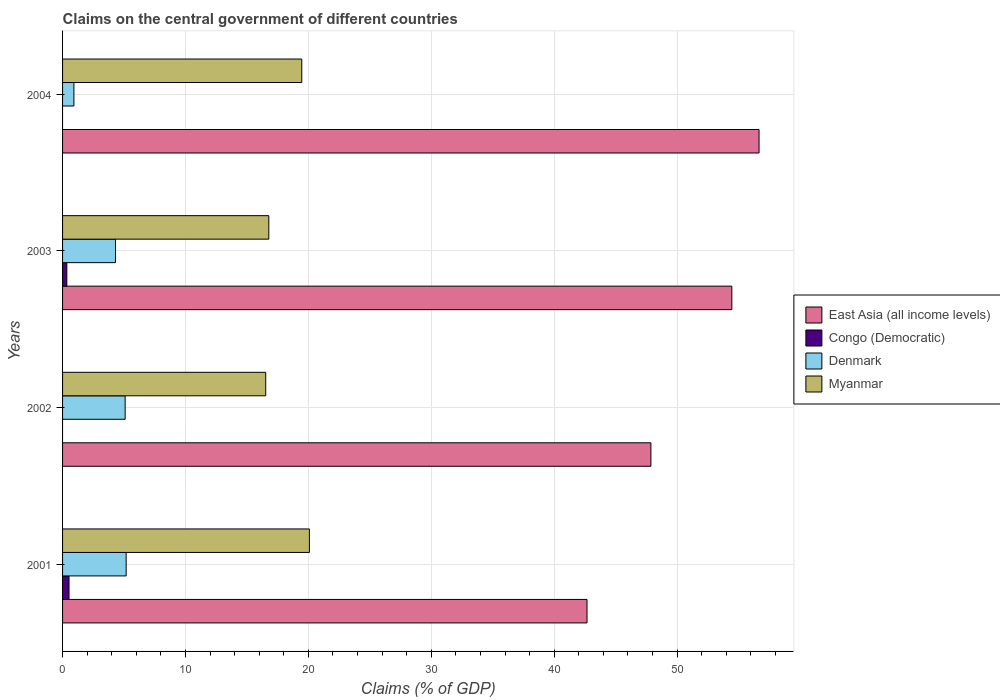How many groups of bars are there?
Offer a very short reply. 4. Are the number of bars on each tick of the Y-axis equal?
Your answer should be very brief. No. How many bars are there on the 3rd tick from the top?
Offer a terse response. 3. What is the label of the 4th group of bars from the top?
Provide a succinct answer. 2001. What is the percentage of GDP claimed on the central government in Myanmar in 2001?
Your answer should be compact. 20.08. Across all years, what is the maximum percentage of GDP claimed on the central government in Denmark?
Offer a very short reply. 5.17. Across all years, what is the minimum percentage of GDP claimed on the central government in East Asia (all income levels)?
Provide a short and direct response. 42.67. What is the total percentage of GDP claimed on the central government in Congo (Democratic) in the graph?
Provide a succinct answer. 0.87. What is the difference between the percentage of GDP claimed on the central government in Myanmar in 2003 and that in 2004?
Ensure brevity in your answer.  -2.68. What is the difference between the percentage of GDP claimed on the central government in East Asia (all income levels) in 2004 and the percentage of GDP claimed on the central government in Myanmar in 2003?
Your answer should be very brief. 39.89. What is the average percentage of GDP claimed on the central government in Congo (Democratic) per year?
Your answer should be compact. 0.22. In the year 2001, what is the difference between the percentage of GDP claimed on the central government in East Asia (all income levels) and percentage of GDP claimed on the central government in Myanmar?
Keep it short and to the point. 22.59. In how many years, is the percentage of GDP claimed on the central government in Congo (Democratic) greater than 12 %?
Provide a succinct answer. 0. What is the ratio of the percentage of GDP claimed on the central government in Myanmar in 2002 to that in 2003?
Provide a short and direct response. 0.98. Is the percentage of GDP claimed on the central government in Denmark in 2001 less than that in 2004?
Make the answer very short. No. Is the difference between the percentage of GDP claimed on the central government in East Asia (all income levels) in 2002 and 2003 greater than the difference between the percentage of GDP claimed on the central government in Myanmar in 2002 and 2003?
Your response must be concise. No. What is the difference between the highest and the second highest percentage of GDP claimed on the central government in Myanmar?
Keep it short and to the point. 0.62. What is the difference between the highest and the lowest percentage of GDP claimed on the central government in Denmark?
Offer a very short reply. 4.25. In how many years, is the percentage of GDP claimed on the central government in Congo (Democratic) greater than the average percentage of GDP claimed on the central government in Congo (Democratic) taken over all years?
Ensure brevity in your answer.  2. Is the sum of the percentage of GDP claimed on the central government in East Asia (all income levels) in 2001 and 2002 greater than the maximum percentage of GDP claimed on the central government in Denmark across all years?
Your response must be concise. Yes. How many bars are there?
Provide a short and direct response. 14. Are all the bars in the graph horizontal?
Ensure brevity in your answer.  Yes. How many years are there in the graph?
Offer a very short reply. 4. Are the values on the major ticks of X-axis written in scientific E-notation?
Provide a short and direct response. No. Does the graph contain any zero values?
Provide a short and direct response. Yes. Does the graph contain grids?
Ensure brevity in your answer.  Yes. Where does the legend appear in the graph?
Offer a very short reply. Center right. How many legend labels are there?
Provide a succinct answer. 4. What is the title of the graph?
Your response must be concise. Claims on the central government of different countries. Does "Latvia" appear as one of the legend labels in the graph?
Your answer should be very brief. No. What is the label or title of the X-axis?
Provide a succinct answer. Claims (% of GDP). What is the label or title of the Y-axis?
Keep it short and to the point. Years. What is the Claims (% of GDP) of East Asia (all income levels) in 2001?
Your answer should be compact. 42.67. What is the Claims (% of GDP) in Congo (Democratic) in 2001?
Offer a terse response. 0.53. What is the Claims (% of GDP) in Denmark in 2001?
Offer a very short reply. 5.17. What is the Claims (% of GDP) of Myanmar in 2001?
Your response must be concise. 20.08. What is the Claims (% of GDP) of East Asia (all income levels) in 2002?
Offer a terse response. 47.87. What is the Claims (% of GDP) in Congo (Democratic) in 2002?
Provide a short and direct response. 0. What is the Claims (% of GDP) of Denmark in 2002?
Offer a very short reply. 5.09. What is the Claims (% of GDP) in Myanmar in 2002?
Your answer should be compact. 16.53. What is the Claims (% of GDP) of East Asia (all income levels) in 2003?
Offer a terse response. 54.45. What is the Claims (% of GDP) of Congo (Democratic) in 2003?
Provide a succinct answer. 0.35. What is the Claims (% of GDP) in Denmark in 2003?
Make the answer very short. 4.31. What is the Claims (% of GDP) of Myanmar in 2003?
Ensure brevity in your answer.  16.78. What is the Claims (% of GDP) of East Asia (all income levels) in 2004?
Offer a terse response. 56.67. What is the Claims (% of GDP) in Denmark in 2004?
Provide a short and direct response. 0.92. What is the Claims (% of GDP) of Myanmar in 2004?
Make the answer very short. 19.46. Across all years, what is the maximum Claims (% of GDP) in East Asia (all income levels)?
Ensure brevity in your answer.  56.67. Across all years, what is the maximum Claims (% of GDP) in Congo (Democratic)?
Provide a succinct answer. 0.53. Across all years, what is the maximum Claims (% of GDP) in Denmark?
Make the answer very short. 5.17. Across all years, what is the maximum Claims (% of GDP) in Myanmar?
Provide a succinct answer. 20.08. Across all years, what is the minimum Claims (% of GDP) of East Asia (all income levels)?
Offer a terse response. 42.67. Across all years, what is the minimum Claims (% of GDP) in Denmark?
Offer a very short reply. 0.92. Across all years, what is the minimum Claims (% of GDP) of Myanmar?
Your answer should be compact. 16.53. What is the total Claims (% of GDP) of East Asia (all income levels) in the graph?
Ensure brevity in your answer.  201.65. What is the total Claims (% of GDP) of Congo (Democratic) in the graph?
Your response must be concise. 0.87. What is the total Claims (% of GDP) of Denmark in the graph?
Give a very brief answer. 15.5. What is the total Claims (% of GDP) in Myanmar in the graph?
Your response must be concise. 72.85. What is the difference between the Claims (% of GDP) in East Asia (all income levels) in 2001 and that in 2002?
Provide a short and direct response. -5.2. What is the difference between the Claims (% of GDP) of Denmark in 2001 and that in 2002?
Provide a succinct answer. 0.08. What is the difference between the Claims (% of GDP) in Myanmar in 2001 and that in 2002?
Give a very brief answer. 3.55. What is the difference between the Claims (% of GDP) in East Asia (all income levels) in 2001 and that in 2003?
Make the answer very short. -11.78. What is the difference between the Claims (% of GDP) in Congo (Democratic) in 2001 and that in 2003?
Your answer should be very brief. 0.18. What is the difference between the Claims (% of GDP) of Denmark in 2001 and that in 2003?
Provide a short and direct response. 0.87. What is the difference between the Claims (% of GDP) in Myanmar in 2001 and that in 2003?
Provide a short and direct response. 3.3. What is the difference between the Claims (% of GDP) in East Asia (all income levels) in 2001 and that in 2004?
Provide a short and direct response. -14. What is the difference between the Claims (% of GDP) in Denmark in 2001 and that in 2004?
Keep it short and to the point. 4.25. What is the difference between the Claims (% of GDP) of Myanmar in 2001 and that in 2004?
Provide a succinct answer. 0.62. What is the difference between the Claims (% of GDP) of East Asia (all income levels) in 2002 and that in 2003?
Offer a very short reply. -6.58. What is the difference between the Claims (% of GDP) of Denmark in 2002 and that in 2003?
Give a very brief answer. 0.78. What is the difference between the Claims (% of GDP) in Myanmar in 2002 and that in 2003?
Give a very brief answer. -0.25. What is the difference between the Claims (% of GDP) in East Asia (all income levels) in 2002 and that in 2004?
Make the answer very short. -8.8. What is the difference between the Claims (% of GDP) in Denmark in 2002 and that in 2004?
Make the answer very short. 4.17. What is the difference between the Claims (% of GDP) of Myanmar in 2002 and that in 2004?
Give a very brief answer. -2.93. What is the difference between the Claims (% of GDP) of East Asia (all income levels) in 2003 and that in 2004?
Make the answer very short. -2.21. What is the difference between the Claims (% of GDP) in Denmark in 2003 and that in 2004?
Give a very brief answer. 3.39. What is the difference between the Claims (% of GDP) in Myanmar in 2003 and that in 2004?
Provide a succinct answer. -2.68. What is the difference between the Claims (% of GDP) in East Asia (all income levels) in 2001 and the Claims (% of GDP) in Denmark in 2002?
Your answer should be compact. 37.58. What is the difference between the Claims (% of GDP) in East Asia (all income levels) in 2001 and the Claims (% of GDP) in Myanmar in 2002?
Offer a terse response. 26.14. What is the difference between the Claims (% of GDP) of Congo (Democratic) in 2001 and the Claims (% of GDP) of Denmark in 2002?
Provide a succinct answer. -4.57. What is the difference between the Claims (% of GDP) in Congo (Democratic) in 2001 and the Claims (% of GDP) in Myanmar in 2002?
Offer a terse response. -16. What is the difference between the Claims (% of GDP) in Denmark in 2001 and the Claims (% of GDP) in Myanmar in 2002?
Offer a terse response. -11.35. What is the difference between the Claims (% of GDP) of East Asia (all income levels) in 2001 and the Claims (% of GDP) of Congo (Democratic) in 2003?
Ensure brevity in your answer.  42.32. What is the difference between the Claims (% of GDP) in East Asia (all income levels) in 2001 and the Claims (% of GDP) in Denmark in 2003?
Your answer should be compact. 38.36. What is the difference between the Claims (% of GDP) of East Asia (all income levels) in 2001 and the Claims (% of GDP) of Myanmar in 2003?
Offer a very short reply. 25.89. What is the difference between the Claims (% of GDP) of Congo (Democratic) in 2001 and the Claims (% of GDP) of Denmark in 2003?
Keep it short and to the point. -3.78. What is the difference between the Claims (% of GDP) in Congo (Democratic) in 2001 and the Claims (% of GDP) in Myanmar in 2003?
Make the answer very short. -16.25. What is the difference between the Claims (% of GDP) of Denmark in 2001 and the Claims (% of GDP) of Myanmar in 2003?
Keep it short and to the point. -11.61. What is the difference between the Claims (% of GDP) of East Asia (all income levels) in 2001 and the Claims (% of GDP) of Denmark in 2004?
Your response must be concise. 41.75. What is the difference between the Claims (% of GDP) in East Asia (all income levels) in 2001 and the Claims (% of GDP) in Myanmar in 2004?
Ensure brevity in your answer.  23.21. What is the difference between the Claims (% of GDP) in Congo (Democratic) in 2001 and the Claims (% of GDP) in Denmark in 2004?
Provide a succinct answer. -0.4. What is the difference between the Claims (% of GDP) of Congo (Democratic) in 2001 and the Claims (% of GDP) of Myanmar in 2004?
Make the answer very short. -18.94. What is the difference between the Claims (% of GDP) of Denmark in 2001 and the Claims (% of GDP) of Myanmar in 2004?
Give a very brief answer. -14.29. What is the difference between the Claims (% of GDP) of East Asia (all income levels) in 2002 and the Claims (% of GDP) of Congo (Democratic) in 2003?
Give a very brief answer. 47.52. What is the difference between the Claims (% of GDP) of East Asia (all income levels) in 2002 and the Claims (% of GDP) of Denmark in 2003?
Provide a short and direct response. 43.56. What is the difference between the Claims (% of GDP) in East Asia (all income levels) in 2002 and the Claims (% of GDP) in Myanmar in 2003?
Keep it short and to the point. 31.09. What is the difference between the Claims (% of GDP) in Denmark in 2002 and the Claims (% of GDP) in Myanmar in 2003?
Your answer should be compact. -11.69. What is the difference between the Claims (% of GDP) of East Asia (all income levels) in 2002 and the Claims (% of GDP) of Denmark in 2004?
Give a very brief answer. 46.94. What is the difference between the Claims (% of GDP) of East Asia (all income levels) in 2002 and the Claims (% of GDP) of Myanmar in 2004?
Give a very brief answer. 28.41. What is the difference between the Claims (% of GDP) of Denmark in 2002 and the Claims (% of GDP) of Myanmar in 2004?
Give a very brief answer. -14.37. What is the difference between the Claims (% of GDP) of East Asia (all income levels) in 2003 and the Claims (% of GDP) of Denmark in 2004?
Offer a terse response. 53.53. What is the difference between the Claims (% of GDP) of East Asia (all income levels) in 2003 and the Claims (% of GDP) of Myanmar in 2004?
Make the answer very short. 34.99. What is the difference between the Claims (% of GDP) in Congo (Democratic) in 2003 and the Claims (% of GDP) in Denmark in 2004?
Your answer should be very brief. -0.58. What is the difference between the Claims (% of GDP) in Congo (Democratic) in 2003 and the Claims (% of GDP) in Myanmar in 2004?
Offer a very short reply. -19.11. What is the difference between the Claims (% of GDP) in Denmark in 2003 and the Claims (% of GDP) in Myanmar in 2004?
Make the answer very short. -15.15. What is the average Claims (% of GDP) in East Asia (all income levels) per year?
Your answer should be compact. 50.41. What is the average Claims (% of GDP) of Congo (Democratic) per year?
Your response must be concise. 0.22. What is the average Claims (% of GDP) in Denmark per year?
Your answer should be very brief. 3.87. What is the average Claims (% of GDP) of Myanmar per year?
Ensure brevity in your answer.  18.21. In the year 2001, what is the difference between the Claims (% of GDP) in East Asia (all income levels) and Claims (% of GDP) in Congo (Democratic)?
Your answer should be compact. 42.14. In the year 2001, what is the difference between the Claims (% of GDP) in East Asia (all income levels) and Claims (% of GDP) in Denmark?
Provide a short and direct response. 37.5. In the year 2001, what is the difference between the Claims (% of GDP) of East Asia (all income levels) and Claims (% of GDP) of Myanmar?
Provide a succinct answer. 22.59. In the year 2001, what is the difference between the Claims (% of GDP) in Congo (Democratic) and Claims (% of GDP) in Denmark?
Offer a very short reply. -4.65. In the year 2001, what is the difference between the Claims (% of GDP) of Congo (Democratic) and Claims (% of GDP) of Myanmar?
Your answer should be compact. -19.56. In the year 2001, what is the difference between the Claims (% of GDP) of Denmark and Claims (% of GDP) of Myanmar?
Keep it short and to the point. -14.91. In the year 2002, what is the difference between the Claims (% of GDP) in East Asia (all income levels) and Claims (% of GDP) in Denmark?
Your response must be concise. 42.78. In the year 2002, what is the difference between the Claims (% of GDP) of East Asia (all income levels) and Claims (% of GDP) of Myanmar?
Your response must be concise. 31.34. In the year 2002, what is the difference between the Claims (% of GDP) of Denmark and Claims (% of GDP) of Myanmar?
Offer a terse response. -11.44. In the year 2003, what is the difference between the Claims (% of GDP) of East Asia (all income levels) and Claims (% of GDP) of Congo (Democratic)?
Your answer should be compact. 54.1. In the year 2003, what is the difference between the Claims (% of GDP) of East Asia (all income levels) and Claims (% of GDP) of Denmark?
Your response must be concise. 50.14. In the year 2003, what is the difference between the Claims (% of GDP) in East Asia (all income levels) and Claims (% of GDP) in Myanmar?
Give a very brief answer. 37.67. In the year 2003, what is the difference between the Claims (% of GDP) of Congo (Democratic) and Claims (% of GDP) of Denmark?
Make the answer very short. -3.96. In the year 2003, what is the difference between the Claims (% of GDP) of Congo (Democratic) and Claims (% of GDP) of Myanmar?
Your answer should be compact. -16.43. In the year 2003, what is the difference between the Claims (% of GDP) of Denmark and Claims (% of GDP) of Myanmar?
Offer a terse response. -12.47. In the year 2004, what is the difference between the Claims (% of GDP) of East Asia (all income levels) and Claims (% of GDP) of Denmark?
Your answer should be compact. 55.74. In the year 2004, what is the difference between the Claims (% of GDP) of East Asia (all income levels) and Claims (% of GDP) of Myanmar?
Offer a very short reply. 37.2. In the year 2004, what is the difference between the Claims (% of GDP) in Denmark and Claims (% of GDP) in Myanmar?
Your response must be concise. -18.54. What is the ratio of the Claims (% of GDP) of East Asia (all income levels) in 2001 to that in 2002?
Give a very brief answer. 0.89. What is the ratio of the Claims (% of GDP) in Denmark in 2001 to that in 2002?
Your answer should be compact. 1.02. What is the ratio of the Claims (% of GDP) of Myanmar in 2001 to that in 2002?
Keep it short and to the point. 1.22. What is the ratio of the Claims (% of GDP) in East Asia (all income levels) in 2001 to that in 2003?
Your response must be concise. 0.78. What is the ratio of the Claims (% of GDP) of Congo (Democratic) in 2001 to that in 2003?
Your response must be concise. 1.52. What is the ratio of the Claims (% of GDP) in Denmark in 2001 to that in 2003?
Offer a terse response. 1.2. What is the ratio of the Claims (% of GDP) of Myanmar in 2001 to that in 2003?
Offer a terse response. 1.2. What is the ratio of the Claims (% of GDP) in East Asia (all income levels) in 2001 to that in 2004?
Ensure brevity in your answer.  0.75. What is the ratio of the Claims (% of GDP) of Denmark in 2001 to that in 2004?
Your answer should be very brief. 5.61. What is the ratio of the Claims (% of GDP) in Myanmar in 2001 to that in 2004?
Keep it short and to the point. 1.03. What is the ratio of the Claims (% of GDP) in East Asia (all income levels) in 2002 to that in 2003?
Ensure brevity in your answer.  0.88. What is the ratio of the Claims (% of GDP) in Denmark in 2002 to that in 2003?
Make the answer very short. 1.18. What is the ratio of the Claims (% of GDP) in East Asia (all income levels) in 2002 to that in 2004?
Ensure brevity in your answer.  0.84. What is the ratio of the Claims (% of GDP) of Denmark in 2002 to that in 2004?
Give a very brief answer. 5.52. What is the ratio of the Claims (% of GDP) in Myanmar in 2002 to that in 2004?
Your response must be concise. 0.85. What is the ratio of the Claims (% of GDP) of East Asia (all income levels) in 2003 to that in 2004?
Your answer should be compact. 0.96. What is the ratio of the Claims (% of GDP) in Denmark in 2003 to that in 2004?
Offer a very short reply. 4.67. What is the ratio of the Claims (% of GDP) in Myanmar in 2003 to that in 2004?
Your answer should be very brief. 0.86. What is the difference between the highest and the second highest Claims (% of GDP) of East Asia (all income levels)?
Offer a terse response. 2.21. What is the difference between the highest and the second highest Claims (% of GDP) in Denmark?
Offer a terse response. 0.08. What is the difference between the highest and the second highest Claims (% of GDP) of Myanmar?
Provide a succinct answer. 0.62. What is the difference between the highest and the lowest Claims (% of GDP) in East Asia (all income levels)?
Offer a terse response. 14. What is the difference between the highest and the lowest Claims (% of GDP) of Congo (Democratic)?
Provide a succinct answer. 0.53. What is the difference between the highest and the lowest Claims (% of GDP) in Denmark?
Your answer should be very brief. 4.25. What is the difference between the highest and the lowest Claims (% of GDP) in Myanmar?
Offer a terse response. 3.55. 